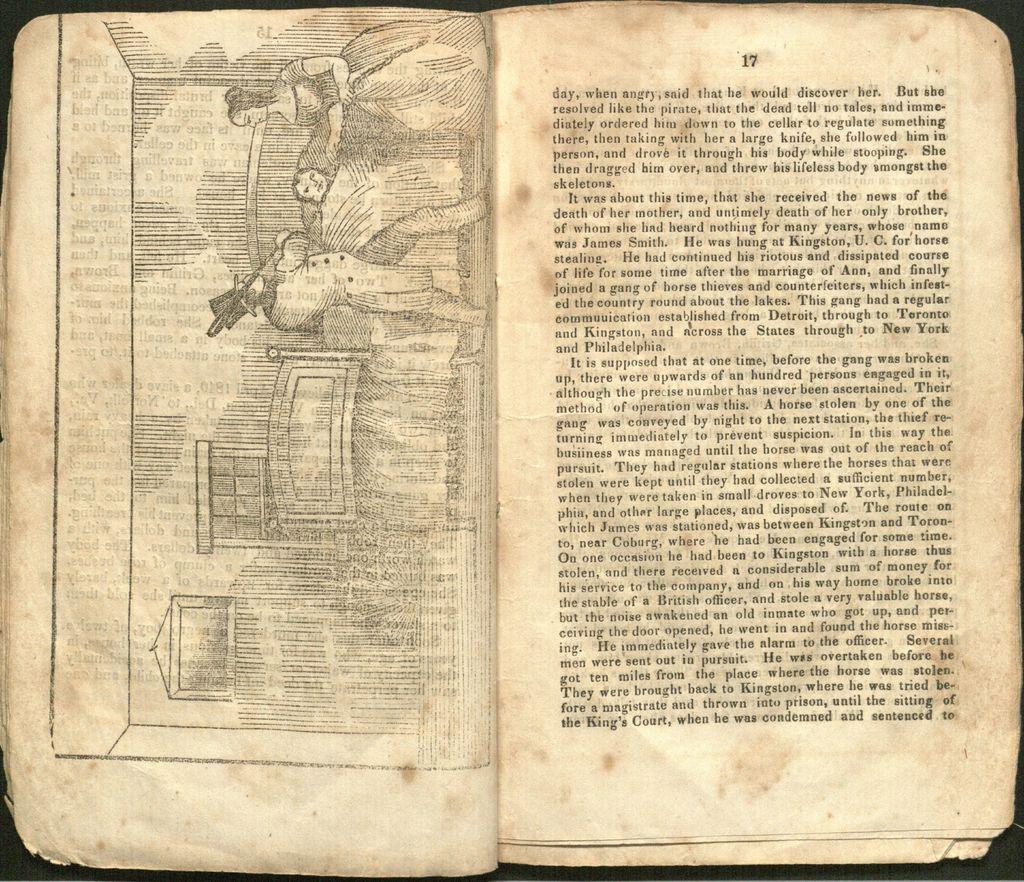What is the page number at the top of the page?
Offer a terse response. 17. 